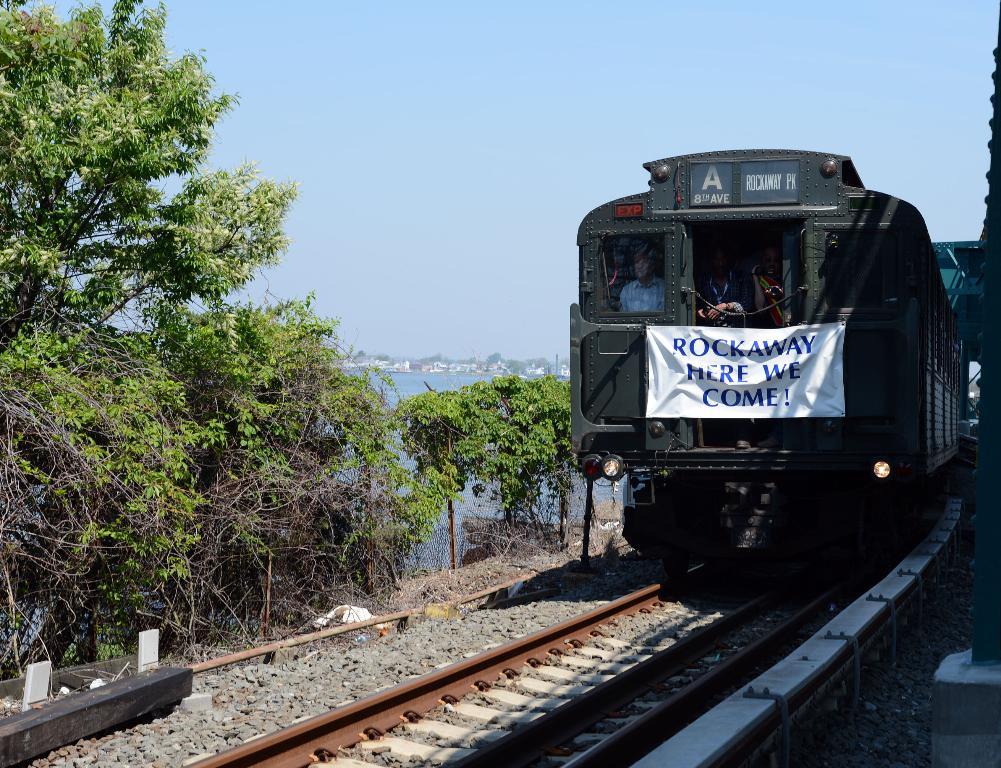Where is this train headed?
Offer a terse response. Rockaway. What does the sign say?
Provide a short and direct response. Rockaway here we come!. 